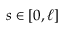<formula> <loc_0><loc_0><loc_500><loc_500>s \in [ 0 , \ell ]</formula> 